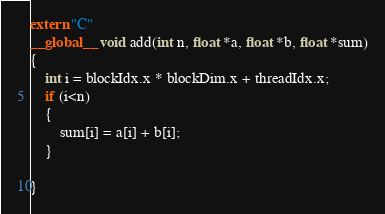<code> <loc_0><loc_0><loc_500><loc_500><_Cuda_>extern "C"
__global__ void add(int n, float *a, float *b, float *sum)
{
    int i = blockIdx.x * blockDim.x + threadIdx.x;
    if (i<n)
    {
        sum[i] = a[i] + b[i];
    }

}
</code> 